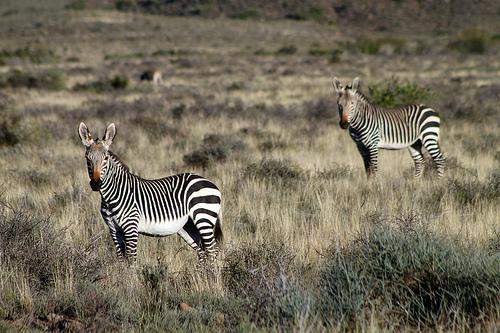Question: what kind of animal is this?
Choices:
A. Tiger.
B. Leopard.
C. Cat.
D. Zebra.
Answer with the letter. Answer: D Question: where are the zebras stripes?
Choices:
A. On its body.
B. On its shirt.
C. On its pants.
D. In its eyes.
Answer with the letter. Answer: A Question: what are the zebras standing in?
Choices:
A. A barn.
B. A field.
C. A zoo.
D. A circus.
Answer with the letter. Answer: B Question: what colors are on the zebras?
Choices:
A. Multicolored.
B. Striped.
C. Brown.
D. Black and white.
Answer with the letter. Answer: D Question: how many people are there?
Choices:
A. None.
B. 3.
C. 5.
D. 2.
Answer with the letter. Answer: A 